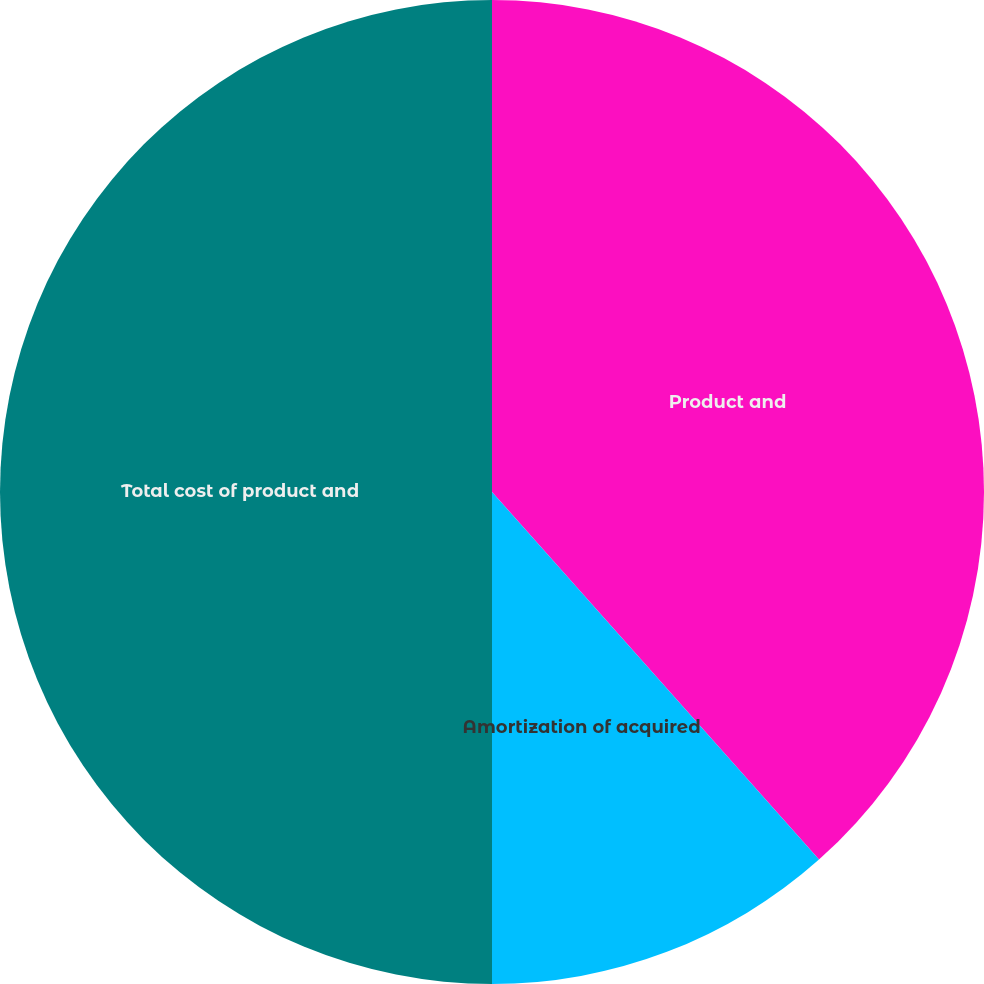Convert chart to OTSL. <chart><loc_0><loc_0><loc_500><loc_500><pie_chart><fcel>Product and<fcel>Amortization of acquired<fcel>Total cost of product and<nl><fcel>38.43%<fcel>11.57%<fcel>50.0%<nl></chart> 